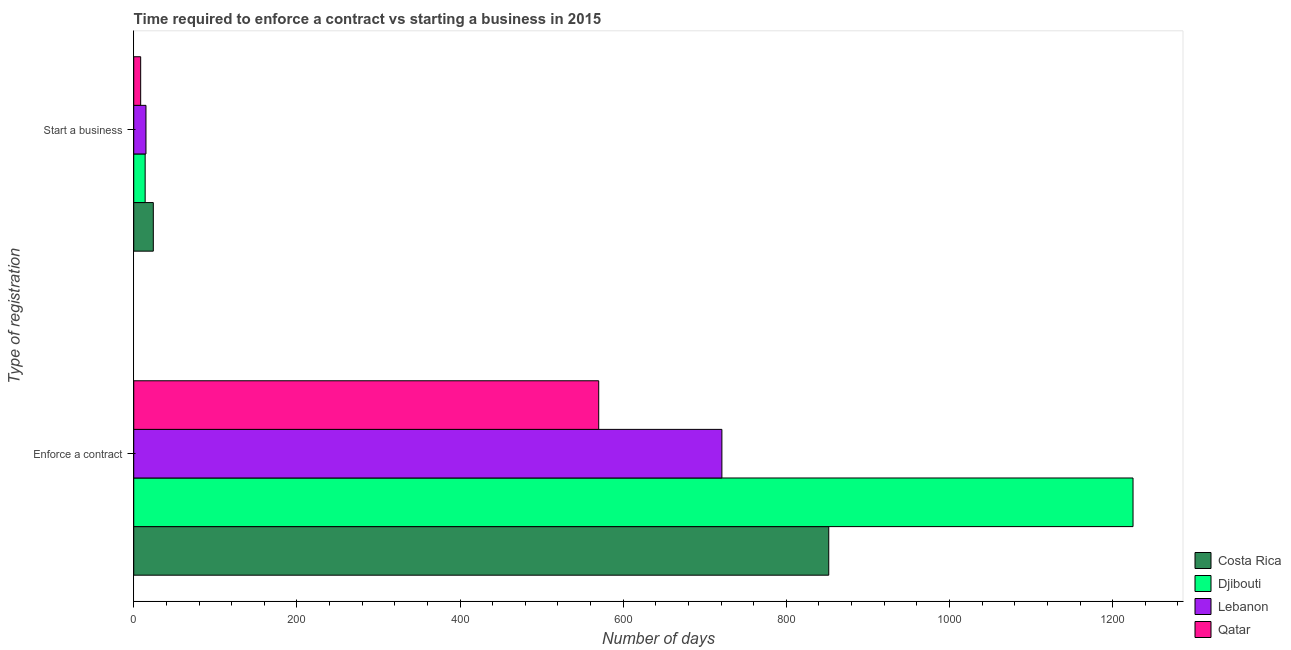How many different coloured bars are there?
Keep it short and to the point. 4. How many bars are there on the 1st tick from the bottom?
Give a very brief answer. 4. What is the label of the 2nd group of bars from the top?
Ensure brevity in your answer.  Enforce a contract. What is the number of days to enforece a contract in Djibouti?
Give a very brief answer. 1225. Across all countries, what is the maximum number of days to enforece a contract?
Offer a very short reply. 1225. Across all countries, what is the minimum number of days to start a business?
Your answer should be very brief. 8.5. In which country was the number of days to start a business minimum?
Your answer should be compact. Qatar. What is the total number of days to start a business in the graph?
Offer a terse response. 61.5. What is the difference between the number of days to start a business in Djibouti and that in Lebanon?
Your answer should be compact. -1. What is the difference between the number of days to enforece a contract in Lebanon and the number of days to start a business in Qatar?
Your response must be concise. 712.5. What is the average number of days to enforece a contract per country?
Keep it short and to the point. 842. What is the difference between the number of days to start a business and number of days to enforece a contract in Qatar?
Ensure brevity in your answer.  -561.5. What is the ratio of the number of days to enforece a contract in Djibouti to that in Lebanon?
Your answer should be very brief. 1.7. What does the 2nd bar from the top in Enforce a contract represents?
Keep it short and to the point. Lebanon. What does the 3rd bar from the bottom in Start a business represents?
Ensure brevity in your answer.  Lebanon. How many bars are there?
Ensure brevity in your answer.  8. Does the graph contain any zero values?
Offer a very short reply. No. What is the title of the graph?
Offer a very short reply. Time required to enforce a contract vs starting a business in 2015. Does "Europe(developing only)" appear as one of the legend labels in the graph?
Keep it short and to the point. No. What is the label or title of the X-axis?
Give a very brief answer. Number of days. What is the label or title of the Y-axis?
Your answer should be very brief. Type of registration. What is the Number of days in Costa Rica in Enforce a contract?
Keep it short and to the point. 852. What is the Number of days of Djibouti in Enforce a contract?
Provide a succinct answer. 1225. What is the Number of days in Lebanon in Enforce a contract?
Offer a very short reply. 721. What is the Number of days in Qatar in Enforce a contract?
Provide a succinct answer. 570. What is the Number of days in Costa Rica in Start a business?
Provide a short and direct response. 24. What is the Number of days of Lebanon in Start a business?
Give a very brief answer. 15. Across all Type of registration, what is the maximum Number of days of Costa Rica?
Your answer should be compact. 852. Across all Type of registration, what is the maximum Number of days in Djibouti?
Provide a short and direct response. 1225. Across all Type of registration, what is the maximum Number of days of Lebanon?
Provide a short and direct response. 721. Across all Type of registration, what is the maximum Number of days in Qatar?
Offer a terse response. 570. Across all Type of registration, what is the minimum Number of days of Djibouti?
Provide a short and direct response. 14. Across all Type of registration, what is the minimum Number of days of Lebanon?
Your response must be concise. 15. What is the total Number of days in Costa Rica in the graph?
Your answer should be compact. 876. What is the total Number of days in Djibouti in the graph?
Offer a terse response. 1239. What is the total Number of days of Lebanon in the graph?
Your answer should be very brief. 736. What is the total Number of days in Qatar in the graph?
Give a very brief answer. 578.5. What is the difference between the Number of days of Costa Rica in Enforce a contract and that in Start a business?
Your answer should be very brief. 828. What is the difference between the Number of days of Djibouti in Enforce a contract and that in Start a business?
Make the answer very short. 1211. What is the difference between the Number of days in Lebanon in Enforce a contract and that in Start a business?
Make the answer very short. 706. What is the difference between the Number of days in Qatar in Enforce a contract and that in Start a business?
Your response must be concise. 561.5. What is the difference between the Number of days in Costa Rica in Enforce a contract and the Number of days in Djibouti in Start a business?
Your answer should be very brief. 838. What is the difference between the Number of days in Costa Rica in Enforce a contract and the Number of days in Lebanon in Start a business?
Provide a succinct answer. 837. What is the difference between the Number of days of Costa Rica in Enforce a contract and the Number of days of Qatar in Start a business?
Your answer should be very brief. 843.5. What is the difference between the Number of days of Djibouti in Enforce a contract and the Number of days of Lebanon in Start a business?
Your answer should be compact. 1210. What is the difference between the Number of days in Djibouti in Enforce a contract and the Number of days in Qatar in Start a business?
Your answer should be very brief. 1216.5. What is the difference between the Number of days of Lebanon in Enforce a contract and the Number of days of Qatar in Start a business?
Provide a short and direct response. 712.5. What is the average Number of days in Costa Rica per Type of registration?
Offer a very short reply. 438. What is the average Number of days of Djibouti per Type of registration?
Ensure brevity in your answer.  619.5. What is the average Number of days in Lebanon per Type of registration?
Give a very brief answer. 368. What is the average Number of days in Qatar per Type of registration?
Provide a succinct answer. 289.25. What is the difference between the Number of days in Costa Rica and Number of days in Djibouti in Enforce a contract?
Provide a short and direct response. -373. What is the difference between the Number of days of Costa Rica and Number of days of Lebanon in Enforce a contract?
Offer a very short reply. 131. What is the difference between the Number of days of Costa Rica and Number of days of Qatar in Enforce a contract?
Your response must be concise. 282. What is the difference between the Number of days of Djibouti and Number of days of Lebanon in Enforce a contract?
Make the answer very short. 504. What is the difference between the Number of days in Djibouti and Number of days in Qatar in Enforce a contract?
Provide a succinct answer. 655. What is the difference between the Number of days in Lebanon and Number of days in Qatar in Enforce a contract?
Offer a very short reply. 151. What is the difference between the Number of days of Costa Rica and Number of days of Djibouti in Start a business?
Make the answer very short. 10. What is the difference between the Number of days in Lebanon and Number of days in Qatar in Start a business?
Your response must be concise. 6.5. What is the ratio of the Number of days of Costa Rica in Enforce a contract to that in Start a business?
Offer a terse response. 35.5. What is the ratio of the Number of days in Djibouti in Enforce a contract to that in Start a business?
Ensure brevity in your answer.  87.5. What is the ratio of the Number of days in Lebanon in Enforce a contract to that in Start a business?
Your response must be concise. 48.07. What is the ratio of the Number of days in Qatar in Enforce a contract to that in Start a business?
Make the answer very short. 67.06. What is the difference between the highest and the second highest Number of days in Costa Rica?
Provide a succinct answer. 828. What is the difference between the highest and the second highest Number of days of Djibouti?
Offer a terse response. 1211. What is the difference between the highest and the second highest Number of days of Lebanon?
Give a very brief answer. 706. What is the difference between the highest and the second highest Number of days in Qatar?
Provide a succinct answer. 561.5. What is the difference between the highest and the lowest Number of days in Costa Rica?
Your answer should be very brief. 828. What is the difference between the highest and the lowest Number of days of Djibouti?
Ensure brevity in your answer.  1211. What is the difference between the highest and the lowest Number of days of Lebanon?
Offer a terse response. 706. What is the difference between the highest and the lowest Number of days of Qatar?
Provide a succinct answer. 561.5. 